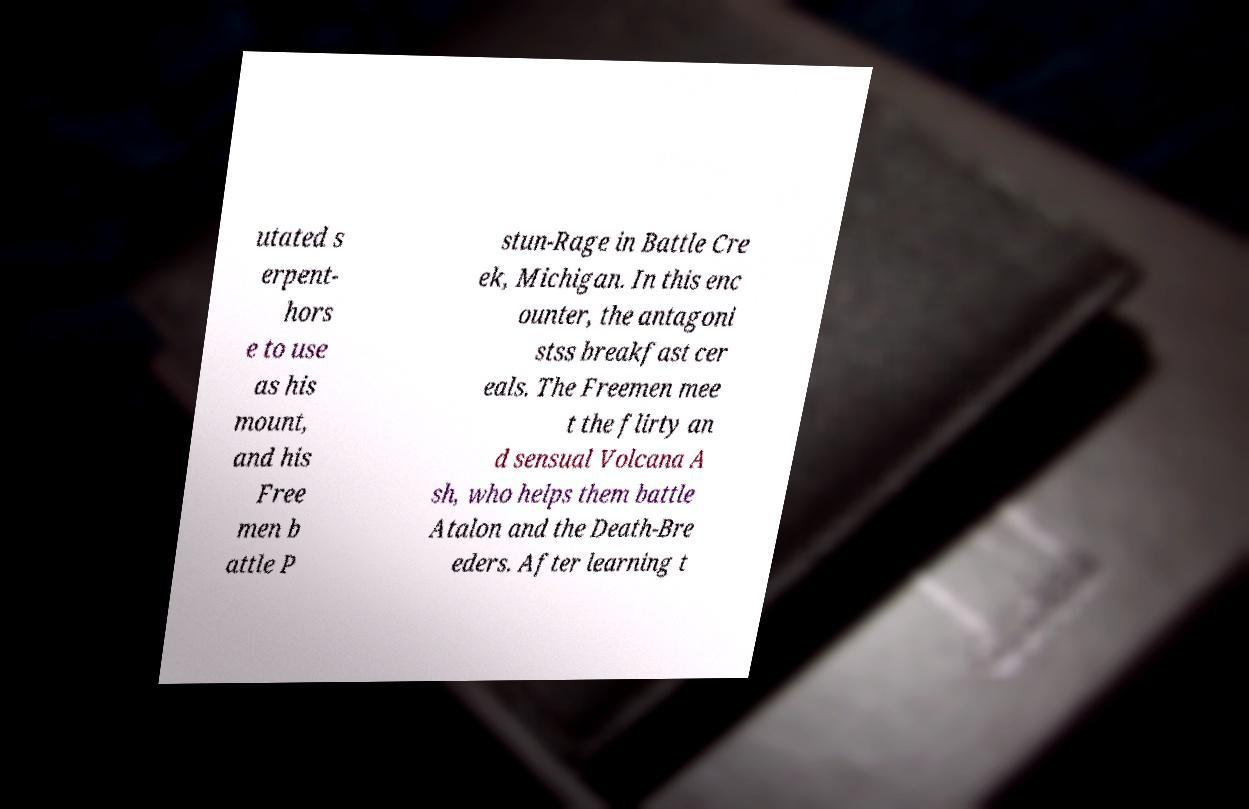Can you accurately transcribe the text from the provided image for me? utated s erpent- hors e to use as his mount, and his Free men b attle P stun-Rage in Battle Cre ek, Michigan. In this enc ounter, the antagoni stss breakfast cer eals. The Freemen mee t the flirty an d sensual Volcana A sh, who helps them battle Atalon and the Death-Bre eders. After learning t 